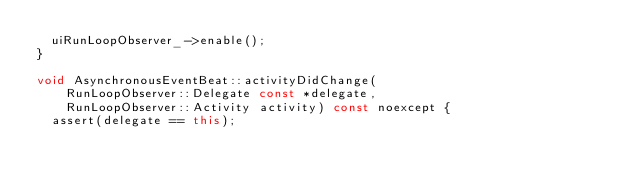<code> <loc_0><loc_0><loc_500><loc_500><_C++_>  uiRunLoopObserver_->enable();
}

void AsynchronousEventBeat::activityDidChange(
    RunLoopObserver::Delegate const *delegate,
    RunLoopObserver::Activity activity) const noexcept {
  assert(delegate == this);</code> 